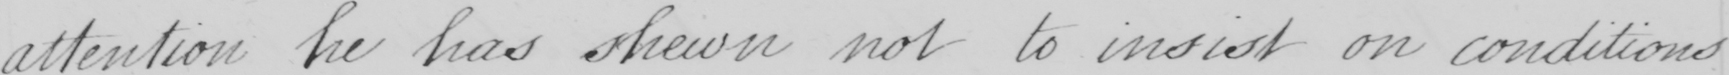Can you read and transcribe this handwriting? attention he has shewn not to insist on conditions 